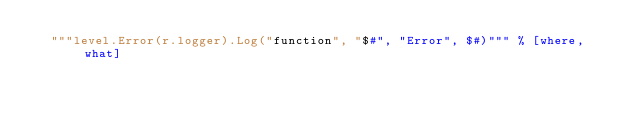<code> <loc_0><loc_0><loc_500><loc_500><_Nim_>  """level.Error(r.logger).Log("function", "$#", "Error", $#)""" % [where, what]
</code> 